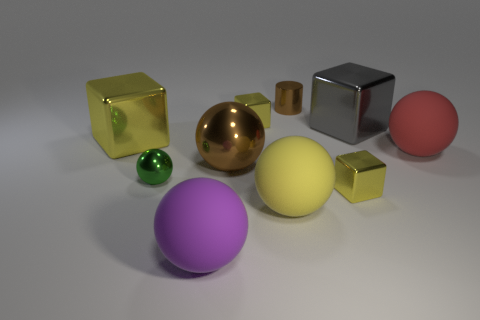How many other things are the same shape as the large gray metal object?
Make the answer very short. 3. Are there the same number of green balls that are to the left of the green metal sphere and brown metallic balls that are left of the purple thing?
Ensure brevity in your answer.  Yes. What is the brown ball made of?
Provide a succinct answer. Metal. What is the material of the tiny yellow thing in front of the red matte object?
Give a very brief answer. Metal. Is there anything else that is the same material as the large red ball?
Offer a terse response. Yes. Are there more shiny cylinders that are to the right of the big brown sphere than small green matte cylinders?
Provide a short and direct response. Yes. Are there any brown shiny spheres that are to the right of the tiny yellow metallic thing that is to the left of the yellow shiny cube that is in front of the big metallic ball?
Offer a very short reply. No. There is a yellow sphere; are there any large brown metallic balls to the right of it?
Keep it short and to the point. No. How many big balls are the same color as the shiny cylinder?
Give a very brief answer. 1. The brown cylinder that is made of the same material as the tiny green thing is what size?
Your answer should be compact. Small. 